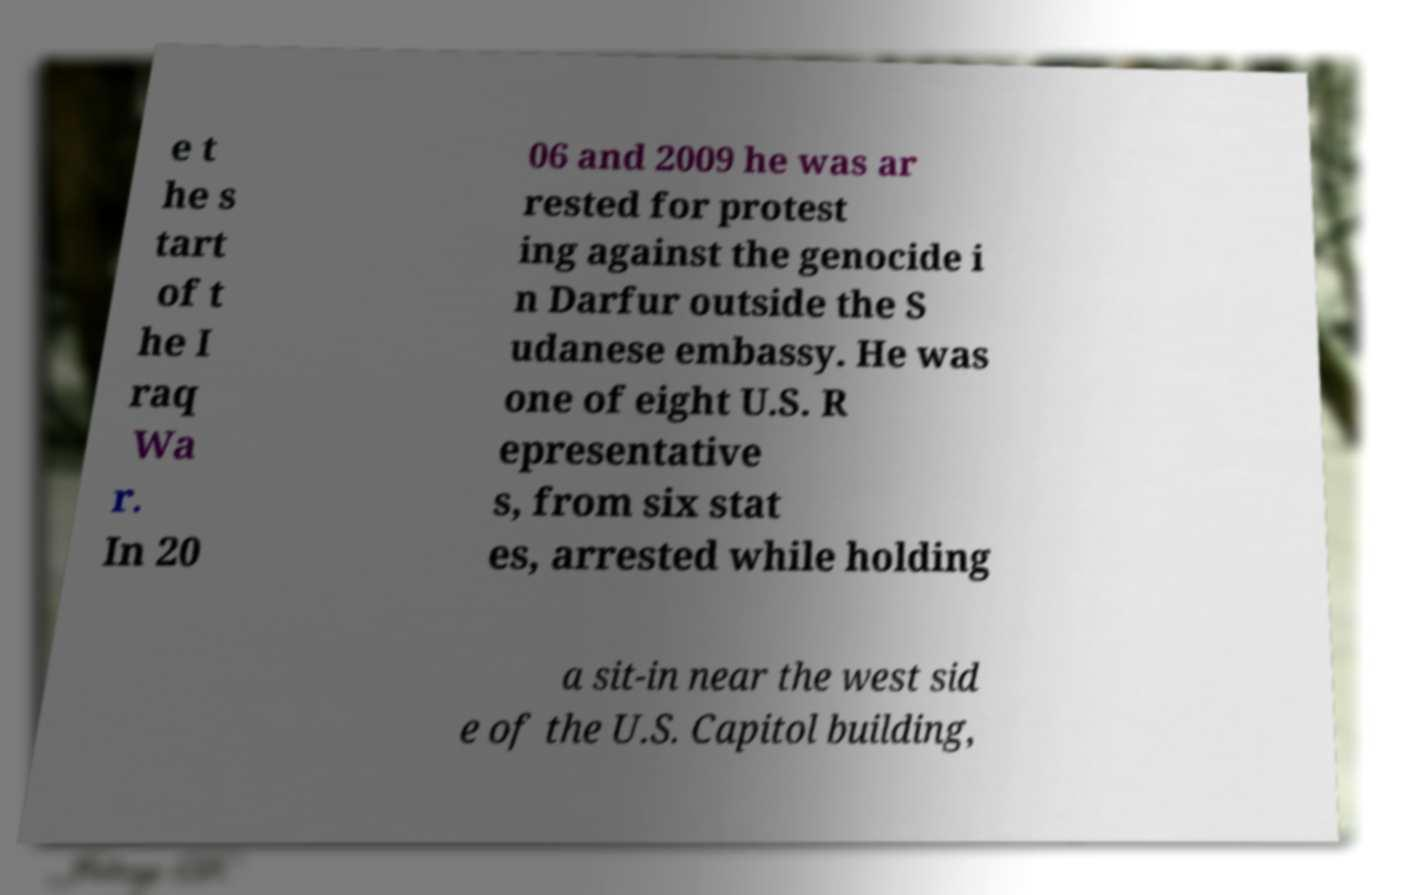Can you read and provide the text displayed in the image?This photo seems to have some interesting text. Can you extract and type it out for me? e t he s tart of t he I raq Wa r. In 20 06 and 2009 he was ar rested for protest ing against the genocide i n Darfur outside the S udanese embassy. He was one of eight U.S. R epresentative s, from six stat es, arrested while holding a sit-in near the west sid e of the U.S. Capitol building, 